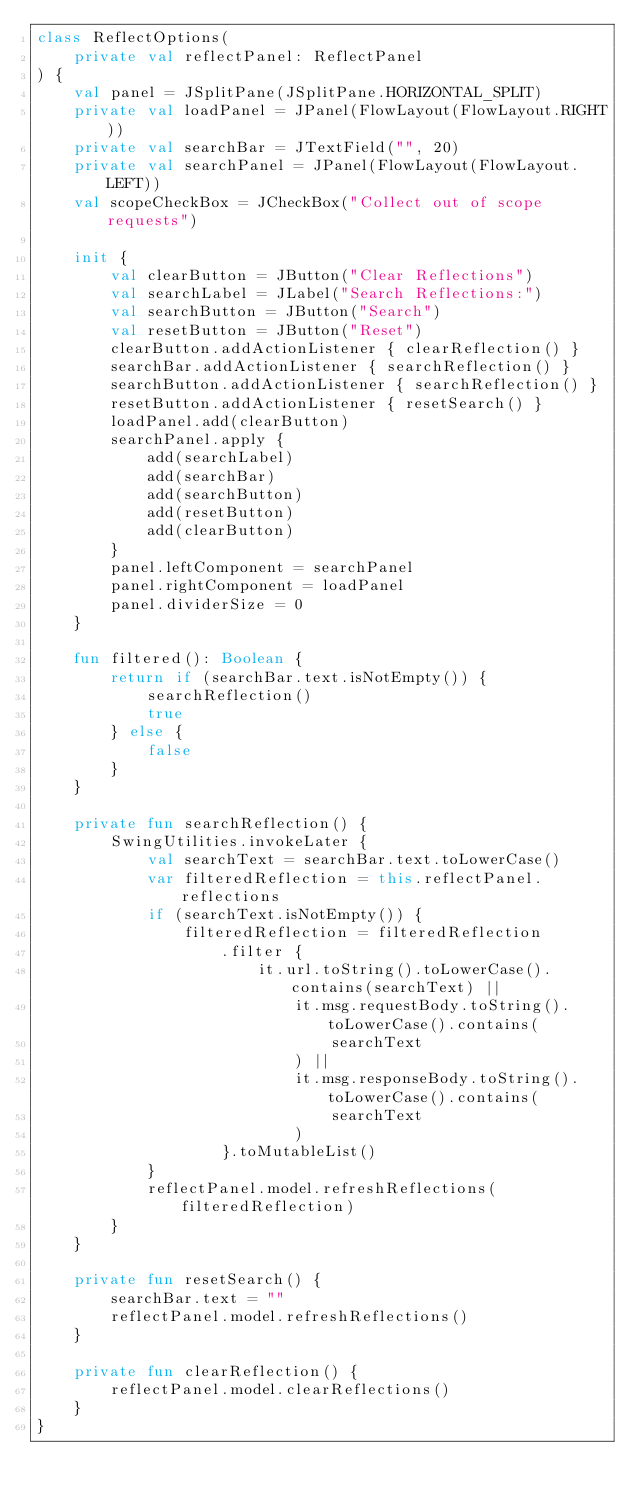Convert code to text. <code><loc_0><loc_0><loc_500><loc_500><_Kotlin_>class ReflectOptions(
    private val reflectPanel: ReflectPanel
) {
    val panel = JSplitPane(JSplitPane.HORIZONTAL_SPLIT)
    private val loadPanel = JPanel(FlowLayout(FlowLayout.RIGHT))
    private val searchBar = JTextField("", 20)
    private val searchPanel = JPanel(FlowLayout(FlowLayout.LEFT))
    val scopeCheckBox = JCheckBox("Collect out of scope requests")

    init {
        val clearButton = JButton("Clear Reflections")
        val searchLabel = JLabel("Search Reflections:")
        val searchButton = JButton("Search")
        val resetButton = JButton("Reset")
        clearButton.addActionListener { clearReflection() }
        searchBar.addActionListener { searchReflection() }
        searchButton.addActionListener { searchReflection() }
        resetButton.addActionListener { resetSearch() }
        loadPanel.add(clearButton)
        searchPanel.apply {
            add(searchLabel)
            add(searchBar)
            add(searchButton)
            add(resetButton)
            add(clearButton)
        }
        panel.leftComponent = searchPanel
        panel.rightComponent = loadPanel
        panel.dividerSize = 0
    }

    fun filtered(): Boolean {
        return if (searchBar.text.isNotEmpty()) {
            searchReflection()
            true
        } else {
            false
        }
    }

    private fun searchReflection() {
        SwingUtilities.invokeLater {
            val searchText = searchBar.text.toLowerCase()
            var filteredReflection = this.reflectPanel.reflections
            if (searchText.isNotEmpty()) {
                filteredReflection = filteredReflection
                    .filter {
                        it.url.toString().toLowerCase().contains(searchText) ||
                            it.msg.requestBody.toString().toLowerCase().contains(
                                searchText
                            ) ||
                            it.msg.responseBody.toString().toLowerCase().contains(
                                searchText
                            )
                    }.toMutableList()
            }
            reflectPanel.model.refreshReflections(filteredReflection)
        }
    }

    private fun resetSearch() {
        searchBar.text = ""
        reflectPanel.model.refreshReflections()
    }

    private fun clearReflection() {
        reflectPanel.model.clearReflections()
    }
}
</code> 